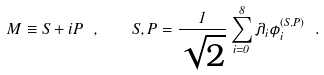<formula> <loc_0><loc_0><loc_500><loc_500>M \equiv S + i P \ , \quad S , P = \frac { 1 } { \sqrt { 2 } } \sum _ { i = 0 } ^ { 8 } \lambda _ { i } \phi _ { i } ^ { ( S , P ) } \ .</formula> 